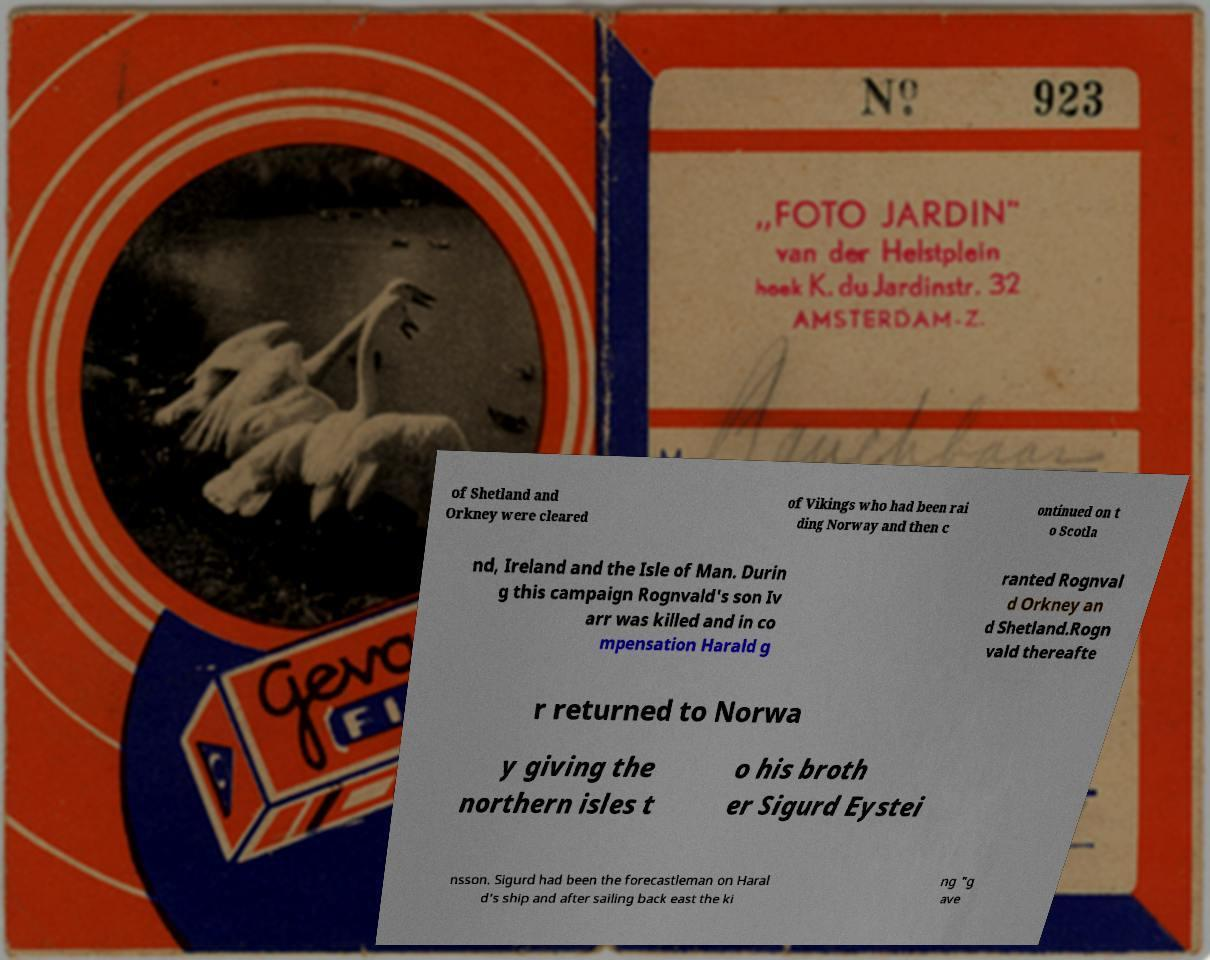Can you read and provide the text displayed in the image?This photo seems to have some interesting text. Can you extract and type it out for me? of Shetland and Orkney were cleared of Vikings who had been rai ding Norway and then c ontinued on t o Scotla nd, Ireland and the Isle of Man. Durin g this campaign Rognvald's son Iv arr was killed and in co mpensation Harald g ranted Rognval d Orkney an d Shetland.Rogn vald thereafte r returned to Norwa y giving the northern isles t o his broth er Sigurd Eystei nsson. Sigurd had been the forecastleman on Haral d's ship and after sailing back east the ki ng "g ave 